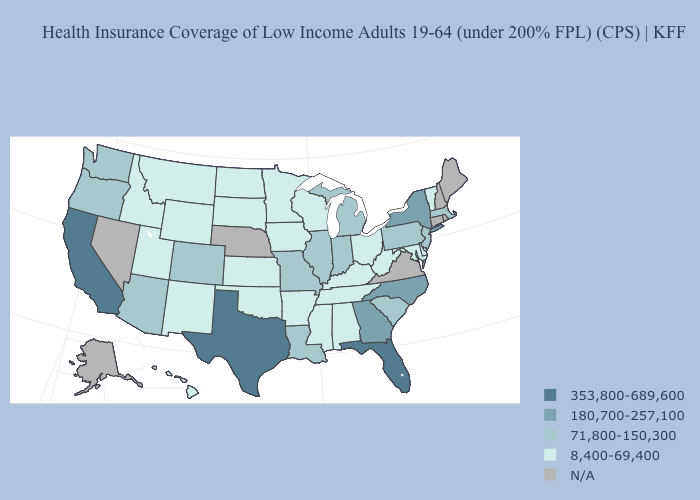What is the value of Tennessee?
Keep it brief. 8,400-69,400. Name the states that have a value in the range 180,700-257,100?
Keep it brief. Georgia, New York, North Carolina. What is the value of North Dakota?
Keep it brief. 8,400-69,400. Among the states that border Oregon , does Washington have the lowest value?
Quick response, please. No. Name the states that have a value in the range 353,800-689,600?
Answer briefly. California, Florida, Texas. What is the highest value in states that border Missouri?
Short answer required. 71,800-150,300. Is the legend a continuous bar?
Quick response, please. No. Among the states that border Utah , which have the highest value?
Answer briefly. Arizona, Colorado. Name the states that have a value in the range 180,700-257,100?
Be succinct. Georgia, New York, North Carolina. Name the states that have a value in the range 180,700-257,100?
Keep it brief. Georgia, New York, North Carolina. Does Vermont have the lowest value in the Northeast?
Concise answer only. Yes. Does New Jersey have the lowest value in the USA?
Quick response, please. No. Name the states that have a value in the range 353,800-689,600?
Concise answer only. California, Florida, Texas. Does Michigan have the highest value in the MidWest?
Short answer required. Yes. 